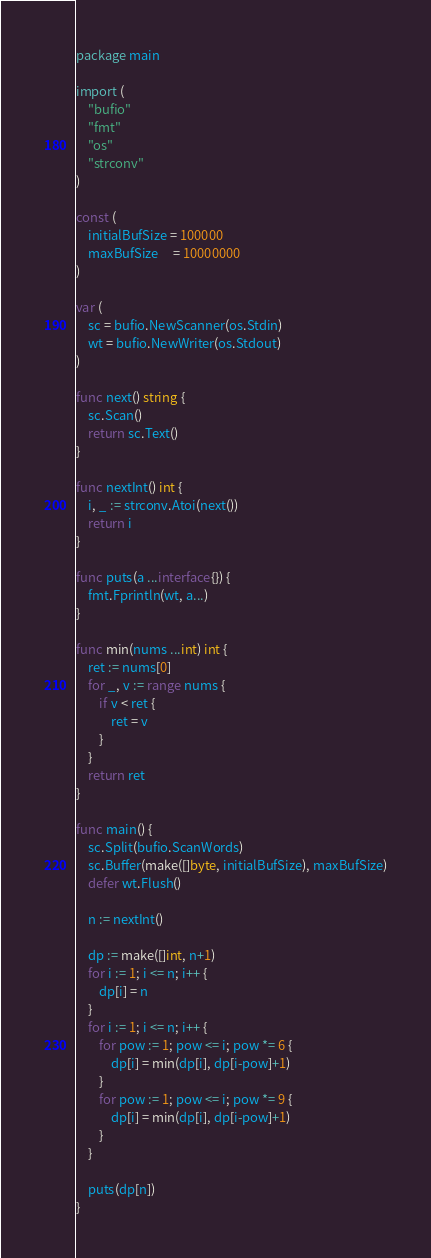Convert code to text. <code><loc_0><loc_0><loc_500><loc_500><_Go_>package main

import (
	"bufio"
	"fmt"
	"os"
	"strconv"
)

const (
	initialBufSize = 100000
	maxBufSize     = 10000000
)

var (
	sc = bufio.NewScanner(os.Stdin)
	wt = bufio.NewWriter(os.Stdout)
)

func next() string {
	sc.Scan()
	return sc.Text()
}

func nextInt() int {
	i, _ := strconv.Atoi(next())
	return i
}

func puts(a ...interface{}) {
	fmt.Fprintln(wt, a...)
}

func min(nums ...int) int {
	ret := nums[0]
	for _, v := range nums {
		if v < ret {
			ret = v
		}
	}
	return ret
}

func main() {
	sc.Split(bufio.ScanWords)
	sc.Buffer(make([]byte, initialBufSize), maxBufSize)
	defer wt.Flush()

	n := nextInt()

	dp := make([]int, n+1)
	for i := 1; i <= n; i++ {
		dp[i] = n
	}
	for i := 1; i <= n; i++ {
		for pow := 1; pow <= i; pow *= 6 {
			dp[i] = min(dp[i], dp[i-pow]+1)
		}
		for pow := 1; pow <= i; pow *= 9 {
			dp[i] = min(dp[i], dp[i-pow]+1)
		}
	}

	puts(dp[n])
}
</code> 